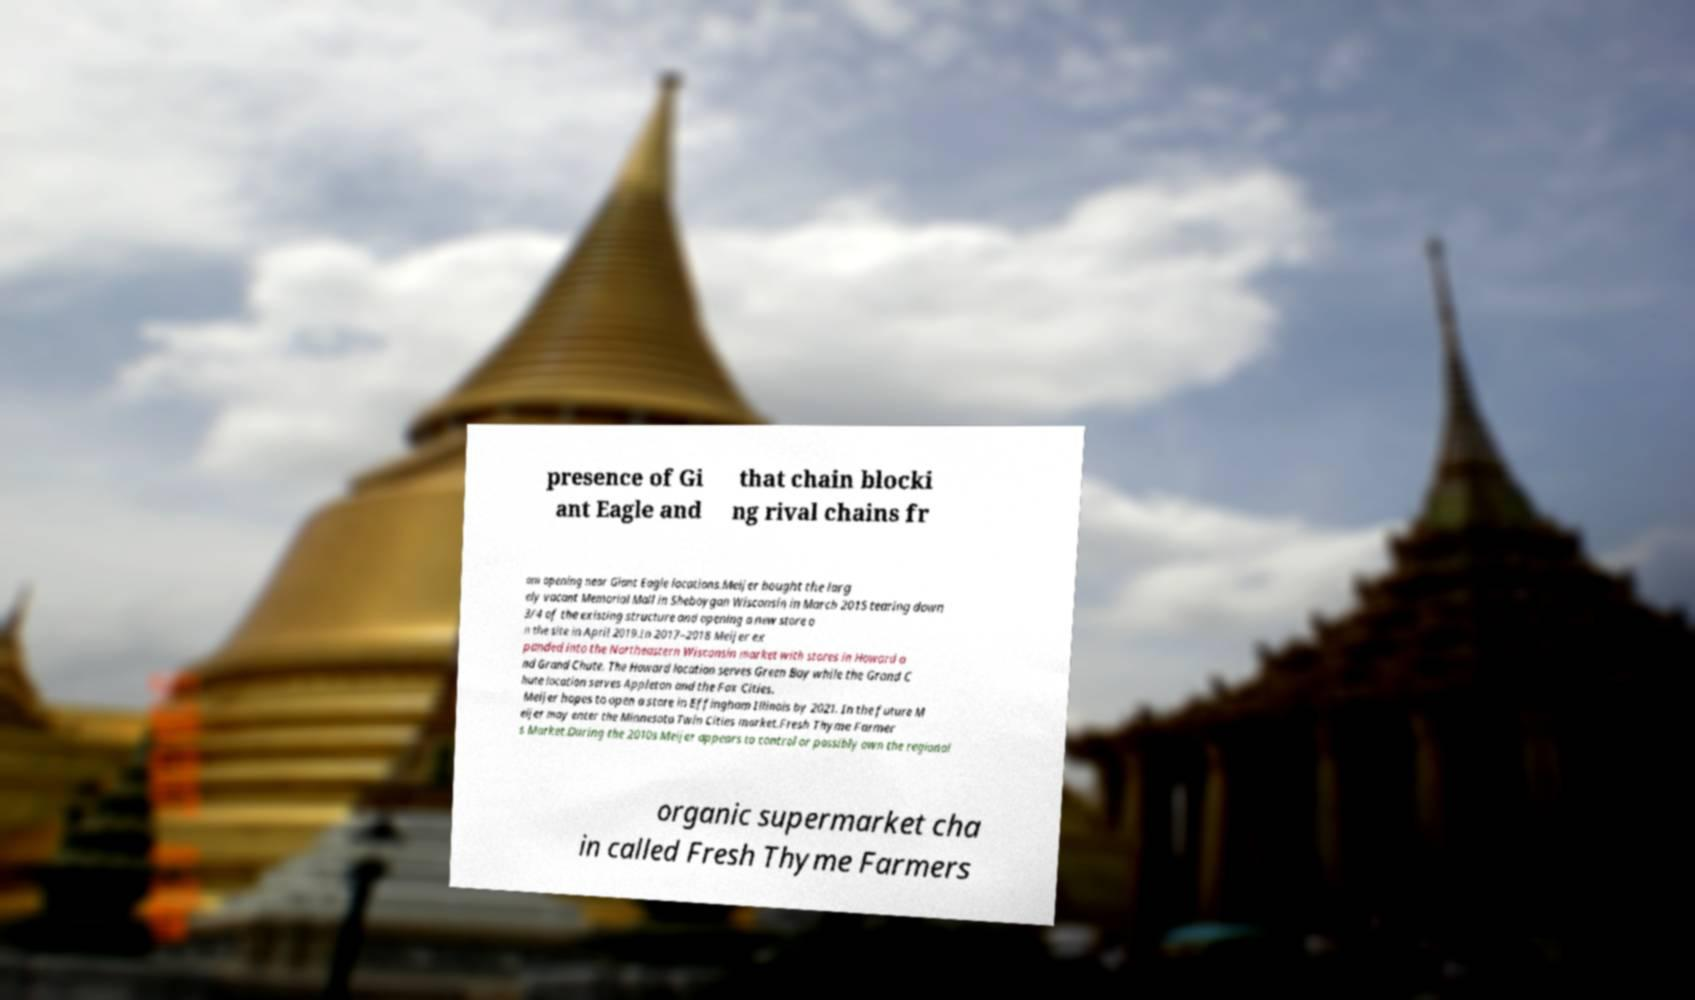Can you read and provide the text displayed in the image?This photo seems to have some interesting text. Can you extract and type it out for me? presence of Gi ant Eagle and that chain blocki ng rival chains fr om opening near Giant Eagle locations.Meijer bought the larg ely vacant Memorial Mall in Sheboygan Wisconsin in March 2015 tearing down 3/4 of the existing structure and opening a new store o n the site in April 2019.In 2017–2018 Meijer ex panded into the Northeastern Wisconsin market with stores in Howard a nd Grand Chute. The Howard location serves Green Bay while the Grand C hute location serves Appleton and the Fox Cities. Meijer hopes to open a store in Effingham Illinois by 2021. In the future M eijer may enter the Minnesota Twin Cities market.Fresh Thyme Farmer s Market.During the 2010s Meijer appears to control or possibly own the regional organic supermarket cha in called Fresh Thyme Farmers 